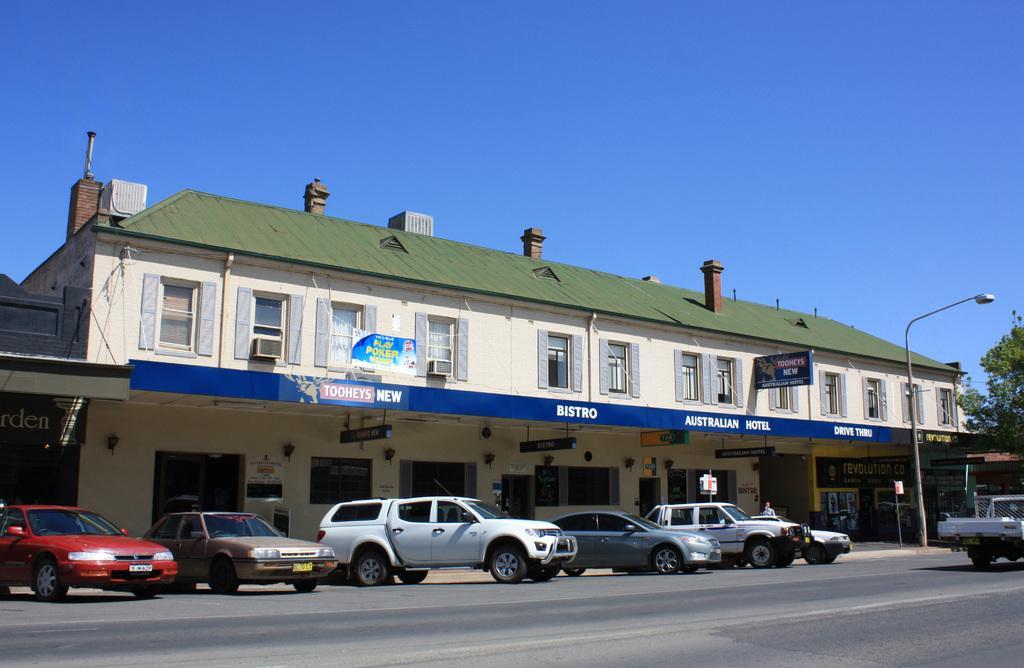In one or two sentences, can you explain what this image depicts? In the center of the image we can see building, windows, boards, air conditioners, doors, lights, flag, electric light pole, stores, cars. At the top of the image there is a sky. At the bottom of the image there is a road. On the right side of the image we can truck, tree. 